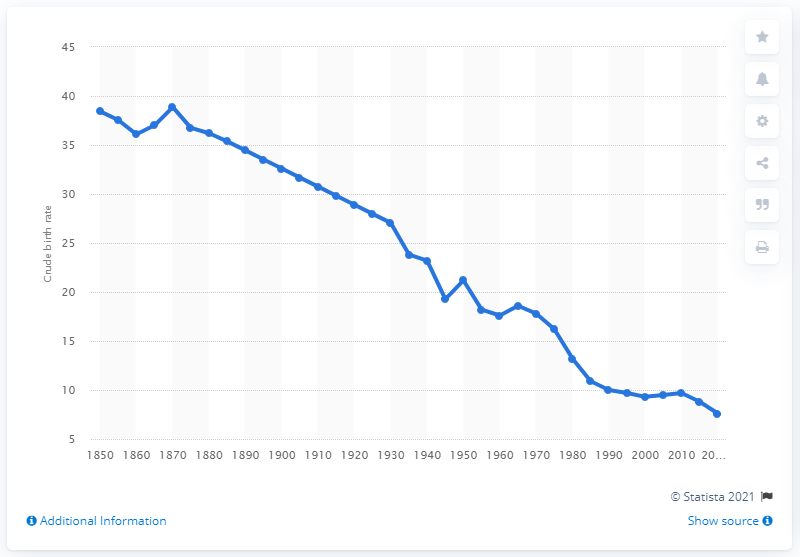Outline some significant characteristics in this image. In 2010, the crude birth rate in Italy was 9.7. 